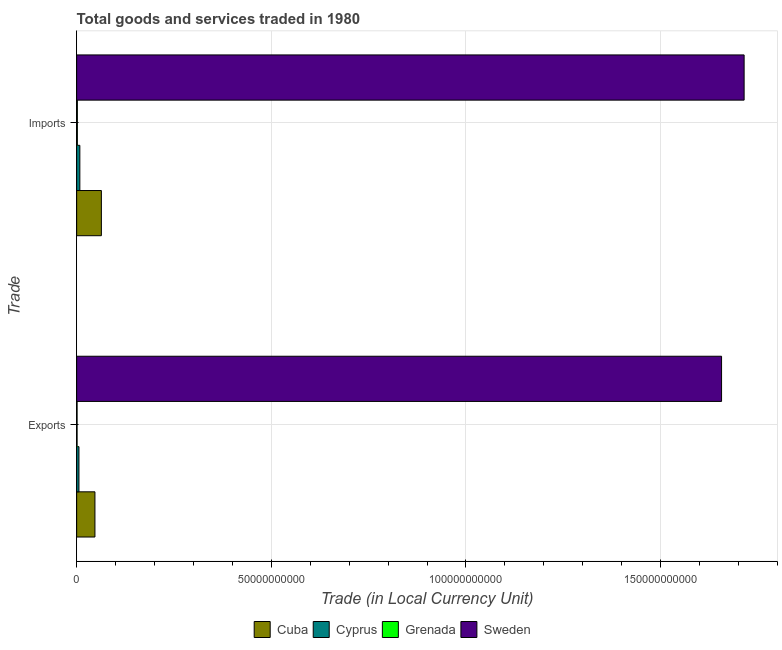How many different coloured bars are there?
Provide a short and direct response. 4. How many bars are there on the 1st tick from the top?
Make the answer very short. 4. What is the label of the 2nd group of bars from the top?
Give a very brief answer. Exports. What is the imports of goods and services in Cuba?
Offer a very short reply. 6.35e+09. Across all countries, what is the maximum export of goods and services?
Offer a terse response. 1.66e+11. Across all countries, what is the minimum export of goods and services?
Make the answer very short. 1.07e+08. In which country was the export of goods and services minimum?
Your response must be concise. Grenada. What is the total imports of goods and services in the graph?
Your answer should be very brief. 1.79e+11. What is the difference between the imports of goods and services in Grenada and that in Cyprus?
Your answer should be compact. -6.40e+08. What is the difference between the imports of goods and services in Cyprus and the export of goods and services in Sweden?
Provide a short and direct response. -1.65e+11. What is the average export of goods and services per country?
Offer a terse response. 4.28e+1. What is the difference between the export of goods and services and imports of goods and services in Sweden?
Make the answer very short. -5.79e+09. In how many countries, is the export of goods and services greater than 30000000000 LCU?
Provide a succinct answer. 1. What is the ratio of the imports of goods and services in Cyprus to that in Sweden?
Your answer should be compact. 0. In how many countries, is the export of goods and services greater than the average export of goods and services taken over all countries?
Provide a short and direct response. 1. What does the 4th bar from the top in Imports represents?
Offer a terse response. Cuba. What does the 2nd bar from the bottom in Exports represents?
Provide a succinct answer. Cyprus. Are all the bars in the graph horizontal?
Offer a very short reply. Yes. Are the values on the major ticks of X-axis written in scientific E-notation?
Offer a terse response. No. Does the graph contain any zero values?
Provide a short and direct response. No. Does the graph contain grids?
Offer a very short reply. Yes. Where does the legend appear in the graph?
Ensure brevity in your answer.  Bottom center. How many legend labels are there?
Give a very brief answer. 4. How are the legend labels stacked?
Provide a short and direct response. Horizontal. What is the title of the graph?
Give a very brief answer. Total goods and services traded in 1980. What is the label or title of the X-axis?
Make the answer very short. Trade (in Local Currency Unit). What is the label or title of the Y-axis?
Give a very brief answer. Trade. What is the Trade (in Local Currency Unit) of Cuba in Exports?
Provide a succinct answer. 4.70e+09. What is the Trade (in Local Currency Unit) of Cyprus in Exports?
Offer a terse response. 5.88e+08. What is the Trade (in Local Currency Unit) of Grenada in Exports?
Your response must be concise. 1.07e+08. What is the Trade (in Local Currency Unit) in Sweden in Exports?
Offer a terse response. 1.66e+11. What is the Trade (in Local Currency Unit) of Cuba in Imports?
Keep it short and to the point. 6.35e+09. What is the Trade (in Local Currency Unit) of Cyprus in Imports?
Ensure brevity in your answer.  8.19e+08. What is the Trade (in Local Currency Unit) of Grenada in Imports?
Offer a terse response. 1.79e+08. What is the Trade (in Local Currency Unit) in Sweden in Imports?
Your answer should be compact. 1.71e+11. Across all Trade, what is the maximum Trade (in Local Currency Unit) of Cuba?
Make the answer very short. 6.35e+09. Across all Trade, what is the maximum Trade (in Local Currency Unit) in Cyprus?
Ensure brevity in your answer.  8.19e+08. Across all Trade, what is the maximum Trade (in Local Currency Unit) in Grenada?
Offer a very short reply. 1.79e+08. Across all Trade, what is the maximum Trade (in Local Currency Unit) in Sweden?
Make the answer very short. 1.71e+11. Across all Trade, what is the minimum Trade (in Local Currency Unit) in Cuba?
Keep it short and to the point. 4.70e+09. Across all Trade, what is the minimum Trade (in Local Currency Unit) in Cyprus?
Ensure brevity in your answer.  5.88e+08. Across all Trade, what is the minimum Trade (in Local Currency Unit) of Grenada?
Offer a very short reply. 1.07e+08. Across all Trade, what is the minimum Trade (in Local Currency Unit) of Sweden?
Make the answer very short. 1.66e+11. What is the total Trade (in Local Currency Unit) in Cuba in the graph?
Your response must be concise. 1.10e+1. What is the total Trade (in Local Currency Unit) of Cyprus in the graph?
Provide a short and direct response. 1.41e+09. What is the total Trade (in Local Currency Unit) in Grenada in the graph?
Your answer should be compact. 2.86e+08. What is the total Trade (in Local Currency Unit) of Sweden in the graph?
Provide a short and direct response. 3.37e+11. What is the difference between the Trade (in Local Currency Unit) in Cuba in Exports and that in Imports?
Provide a short and direct response. -1.65e+09. What is the difference between the Trade (in Local Currency Unit) of Cyprus in Exports and that in Imports?
Provide a short and direct response. -2.31e+08. What is the difference between the Trade (in Local Currency Unit) in Grenada in Exports and that in Imports?
Make the answer very short. -7.23e+07. What is the difference between the Trade (in Local Currency Unit) of Sweden in Exports and that in Imports?
Provide a succinct answer. -5.79e+09. What is the difference between the Trade (in Local Currency Unit) in Cuba in Exports and the Trade (in Local Currency Unit) in Cyprus in Imports?
Your response must be concise. 3.88e+09. What is the difference between the Trade (in Local Currency Unit) in Cuba in Exports and the Trade (in Local Currency Unit) in Grenada in Imports?
Provide a succinct answer. 4.52e+09. What is the difference between the Trade (in Local Currency Unit) of Cuba in Exports and the Trade (in Local Currency Unit) of Sweden in Imports?
Offer a very short reply. -1.67e+11. What is the difference between the Trade (in Local Currency Unit) of Cyprus in Exports and the Trade (in Local Currency Unit) of Grenada in Imports?
Provide a short and direct response. 4.09e+08. What is the difference between the Trade (in Local Currency Unit) of Cyprus in Exports and the Trade (in Local Currency Unit) of Sweden in Imports?
Your answer should be compact. -1.71e+11. What is the difference between the Trade (in Local Currency Unit) of Grenada in Exports and the Trade (in Local Currency Unit) of Sweden in Imports?
Make the answer very short. -1.71e+11. What is the average Trade (in Local Currency Unit) in Cuba per Trade?
Ensure brevity in your answer.  5.52e+09. What is the average Trade (in Local Currency Unit) in Cyprus per Trade?
Your answer should be compact. 7.04e+08. What is the average Trade (in Local Currency Unit) in Grenada per Trade?
Ensure brevity in your answer.  1.43e+08. What is the average Trade (in Local Currency Unit) in Sweden per Trade?
Offer a very short reply. 1.69e+11. What is the difference between the Trade (in Local Currency Unit) in Cuba and Trade (in Local Currency Unit) in Cyprus in Exports?
Your answer should be compact. 4.11e+09. What is the difference between the Trade (in Local Currency Unit) of Cuba and Trade (in Local Currency Unit) of Grenada in Exports?
Offer a terse response. 4.59e+09. What is the difference between the Trade (in Local Currency Unit) of Cuba and Trade (in Local Currency Unit) of Sweden in Exports?
Provide a short and direct response. -1.61e+11. What is the difference between the Trade (in Local Currency Unit) of Cyprus and Trade (in Local Currency Unit) of Grenada in Exports?
Offer a terse response. 4.81e+08. What is the difference between the Trade (in Local Currency Unit) of Cyprus and Trade (in Local Currency Unit) of Sweden in Exports?
Provide a short and direct response. -1.65e+11. What is the difference between the Trade (in Local Currency Unit) of Grenada and Trade (in Local Currency Unit) of Sweden in Exports?
Make the answer very short. -1.66e+11. What is the difference between the Trade (in Local Currency Unit) of Cuba and Trade (in Local Currency Unit) of Cyprus in Imports?
Your answer should be very brief. 5.53e+09. What is the difference between the Trade (in Local Currency Unit) of Cuba and Trade (in Local Currency Unit) of Grenada in Imports?
Offer a terse response. 6.17e+09. What is the difference between the Trade (in Local Currency Unit) of Cuba and Trade (in Local Currency Unit) of Sweden in Imports?
Offer a terse response. -1.65e+11. What is the difference between the Trade (in Local Currency Unit) of Cyprus and Trade (in Local Currency Unit) of Grenada in Imports?
Provide a succinct answer. 6.40e+08. What is the difference between the Trade (in Local Currency Unit) of Cyprus and Trade (in Local Currency Unit) of Sweden in Imports?
Your answer should be compact. -1.71e+11. What is the difference between the Trade (in Local Currency Unit) of Grenada and Trade (in Local Currency Unit) of Sweden in Imports?
Your response must be concise. -1.71e+11. What is the ratio of the Trade (in Local Currency Unit) in Cuba in Exports to that in Imports?
Your response must be concise. 0.74. What is the ratio of the Trade (in Local Currency Unit) in Cyprus in Exports to that in Imports?
Keep it short and to the point. 0.72. What is the ratio of the Trade (in Local Currency Unit) in Grenada in Exports to that in Imports?
Keep it short and to the point. 0.6. What is the ratio of the Trade (in Local Currency Unit) in Sweden in Exports to that in Imports?
Provide a short and direct response. 0.97. What is the difference between the highest and the second highest Trade (in Local Currency Unit) of Cuba?
Keep it short and to the point. 1.65e+09. What is the difference between the highest and the second highest Trade (in Local Currency Unit) of Cyprus?
Provide a short and direct response. 2.31e+08. What is the difference between the highest and the second highest Trade (in Local Currency Unit) of Grenada?
Provide a short and direct response. 7.23e+07. What is the difference between the highest and the second highest Trade (in Local Currency Unit) in Sweden?
Your answer should be very brief. 5.79e+09. What is the difference between the highest and the lowest Trade (in Local Currency Unit) of Cuba?
Your answer should be compact. 1.65e+09. What is the difference between the highest and the lowest Trade (in Local Currency Unit) of Cyprus?
Your answer should be compact. 2.31e+08. What is the difference between the highest and the lowest Trade (in Local Currency Unit) of Grenada?
Make the answer very short. 7.23e+07. What is the difference between the highest and the lowest Trade (in Local Currency Unit) of Sweden?
Offer a very short reply. 5.79e+09. 